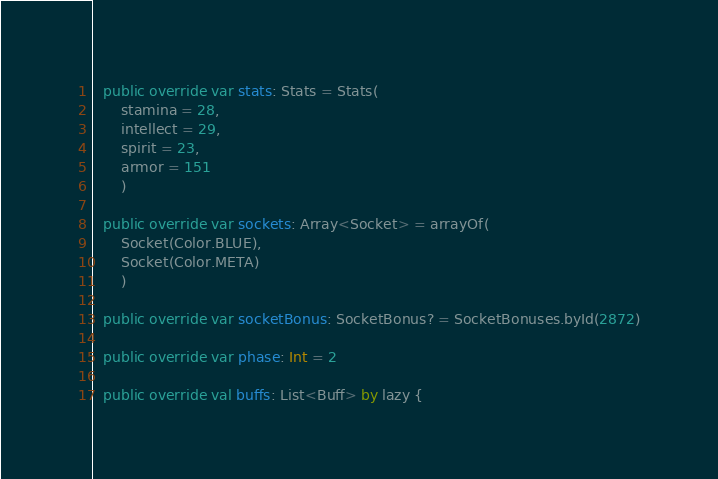<code> <loc_0><loc_0><loc_500><loc_500><_Kotlin_>
  public override var stats: Stats = Stats(
      stamina = 28,
      intellect = 29,
      spirit = 23,
      armor = 151
      )

  public override var sockets: Array<Socket> = arrayOf(
      Socket(Color.BLUE),
      Socket(Color.META)
      )

  public override var socketBonus: SocketBonus? = SocketBonuses.byId(2872)

  public override var phase: Int = 2

  public override val buffs: List<Buff> by lazy {</code> 